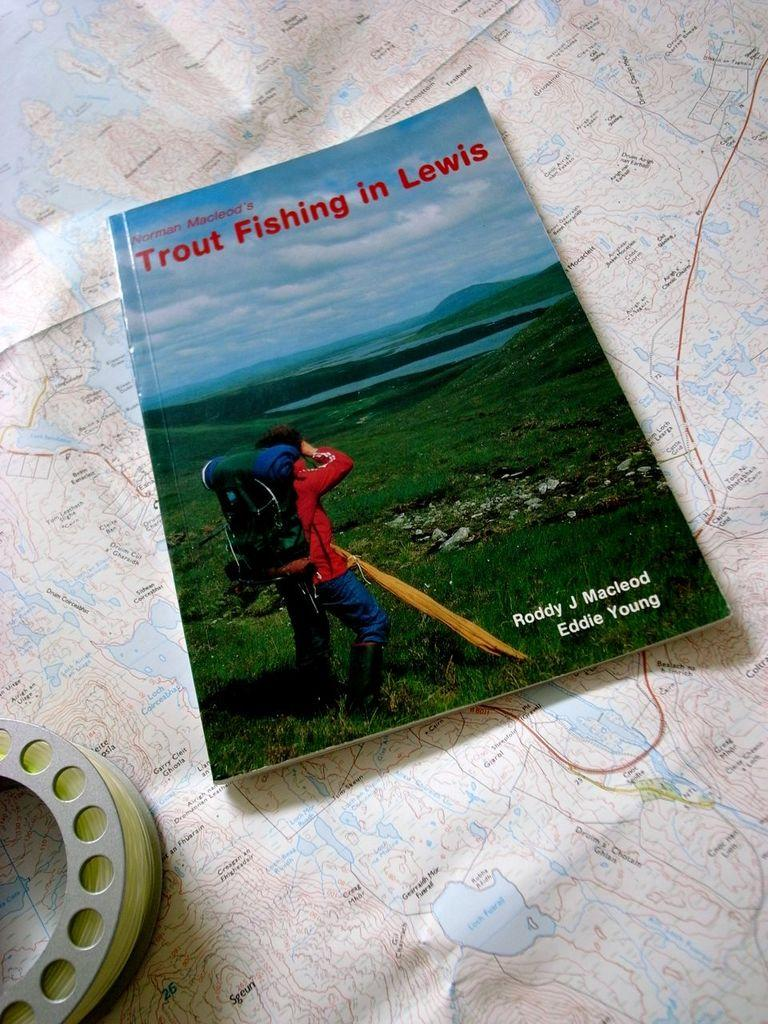<image>
Share a concise interpretation of the image provided. A book placed on a map titled Trout Fishing in Lewis. 